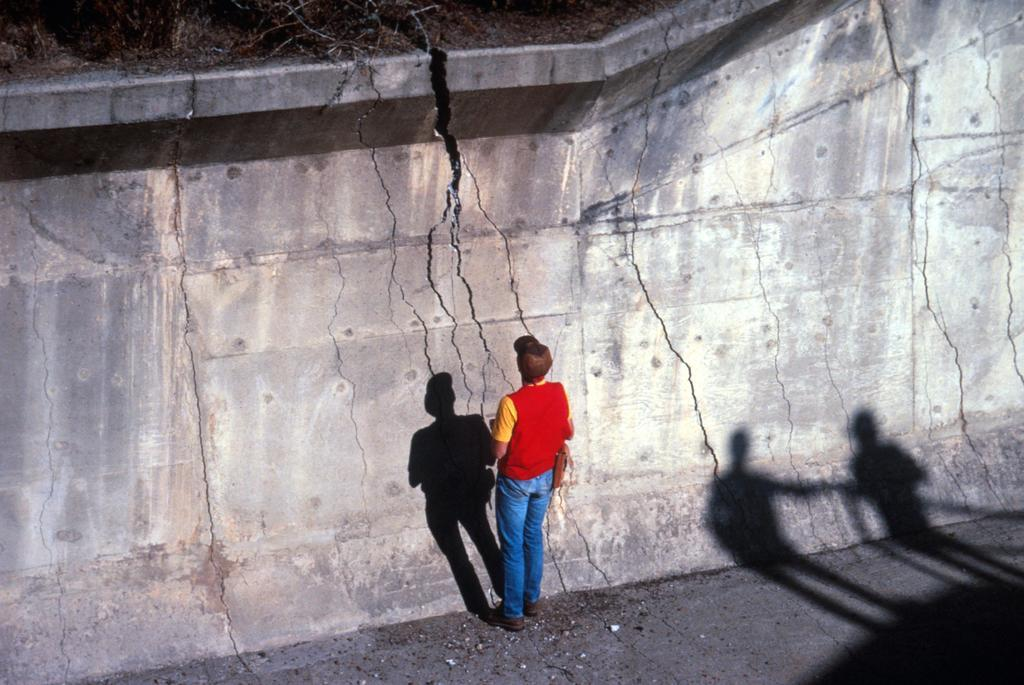What is the main subject of the image? There is a person standing in the image. Where is the person standing? The person is standing on the ground. What can be seen on the wall in the image? There are shadows on the wall in the image. What type of vegetation is visible in the image? There are plants visible in the image. What type of throne is the person sitting on in the image? There is no throne present in the image; the person is standing on the ground. What color is the coat the person is wearing in the image? There is no coat visible in the image, as the person is not wearing one. 